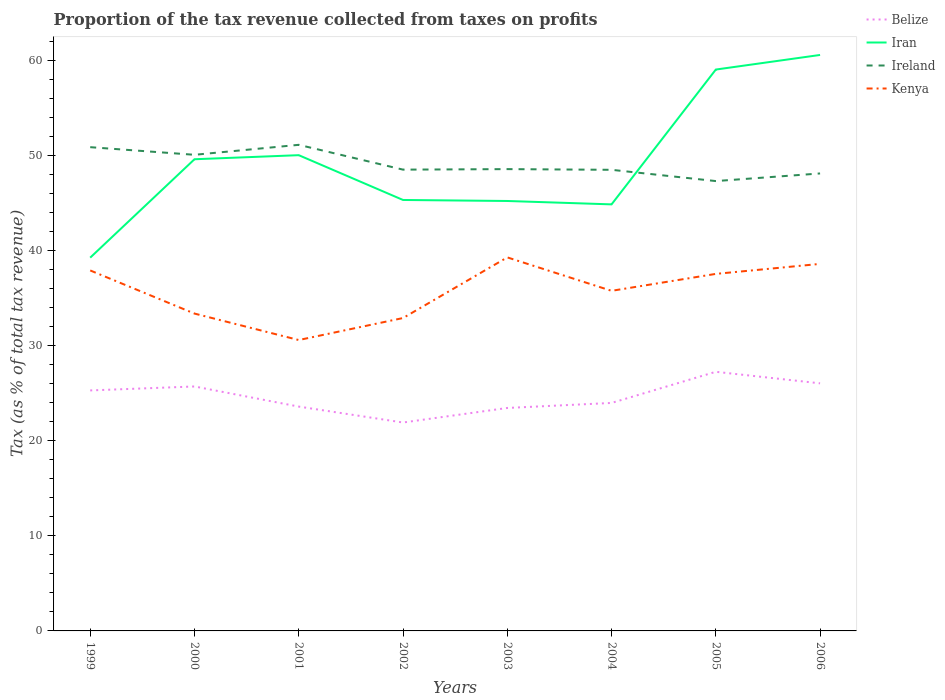How many different coloured lines are there?
Ensure brevity in your answer.  4. Does the line corresponding to Ireland intersect with the line corresponding to Kenya?
Your answer should be very brief. No. Across all years, what is the maximum proportion of the tax revenue collected in Ireland?
Provide a succinct answer. 47.34. What is the total proportion of the tax revenue collected in Kenya in the graph?
Your response must be concise. 5.01. What is the difference between the highest and the second highest proportion of the tax revenue collected in Ireland?
Provide a succinct answer. 3.81. Is the proportion of the tax revenue collected in Ireland strictly greater than the proportion of the tax revenue collected in Iran over the years?
Your answer should be very brief. No. What is the difference between two consecutive major ticks on the Y-axis?
Give a very brief answer. 10. Are the values on the major ticks of Y-axis written in scientific E-notation?
Your answer should be very brief. No. Does the graph contain grids?
Ensure brevity in your answer.  No. How are the legend labels stacked?
Make the answer very short. Vertical. What is the title of the graph?
Your answer should be very brief. Proportion of the tax revenue collected from taxes on profits. Does "Macedonia" appear as one of the legend labels in the graph?
Ensure brevity in your answer.  No. What is the label or title of the X-axis?
Provide a short and direct response. Years. What is the label or title of the Y-axis?
Make the answer very short. Tax (as % of total tax revenue). What is the Tax (as % of total tax revenue) of Belize in 1999?
Your response must be concise. 25.31. What is the Tax (as % of total tax revenue) in Iran in 1999?
Provide a short and direct response. 39.28. What is the Tax (as % of total tax revenue) of Ireland in 1999?
Offer a very short reply. 50.91. What is the Tax (as % of total tax revenue) of Kenya in 1999?
Offer a very short reply. 37.93. What is the Tax (as % of total tax revenue) in Belize in 2000?
Keep it short and to the point. 25.72. What is the Tax (as % of total tax revenue) of Iran in 2000?
Ensure brevity in your answer.  49.64. What is the Tax (as % of total tax revenue) of Ireland in 2000?
Make the answer very short. 50.11. What is the Tax (as % of total tax revenue) of Kenya in 2000?
Your answer should be very brief. 33.4. What is the Tax (as % of total tax revenue) in Belize in 2001?
Your response must be concise. 23.61. What is the Tax (as % of total tax revenue) of Iran in 2001?
Ensure brevity in your answer.  50.07. What is the Tax (as % of total tax revenue) of Ireland in 2001?
Offer a very short reply. 51.15. What is the Tax (as % of total tax revenue) of Kenya in 2001?
Provide a short and direct response. 30.61. What is the Tax (as % of total tax revenue) in Belize in 2002?
Ensure brevity in your answer.  21.93. What is the Tax (as % of total tax revenue) in Iran in 2002?
Your response must be concise. 45.35. What is the Tax (as % of total tax revenue) in Ireland in 2002?
Provide a succinct answer. 48.54. What is the Tax (as % of total tax revenue) in Kenya in 2002?
Provide a short and direct response. 32.93. What is the Tax (as % of total tax revenue) of Belize in 2003?
Provide a succinct answer. 23.46. What is the Tax (as % of total tax revenue) of Iran in 2003?
Your answer should be compact. 45.24. What is the Tax (as % of total tax revenue) in Ireland in 2003?
Make the answer very short. 48.6. What is the Tax (as % of total tax revenue) of Kenya in 2003?
Offer a terse response. 39.31. What is the Tax (as % of total tax revenue) of Belize in 2004?
Your response must be concise. 23.99. What is the Tax (as % of total tax revenue) of Iran in 2004?
Offer a very short reply. 44.89. What is the Tax (as % of total tax revenue) of Ireland in 2004?
Ensure brevity in your answer.  48.53. What is the Tax (as % of total tax revenue) in Kenya in 2004?
Your answer should be compact. 35.79. What is the Tax (as % of total tax revenue) in Belize in 2005?
Give a very brief answer. 27.27. What is the Tax (as % of total tax revenue) of Iran in 2005?
Your response must be concise. 59.08. What is the Tax (as % of total tax revenue) of Ireland in 2005?
Give a very brief answer. 47.34. What is the Tax (as % of total tax revenue) in Kenya in 2005?
Offer a very short reply. 37.57. What is the Tax (as % of total tax revenue) in Belize in 2006?
Offer a terse response. 26.05. What is the Tax (as % of total tax revenue) in Iran in 2006?
Make the answer very short. 60.61. What is the Tax (as % of total tax revenue) in Ireland in 2006?
Your answer should be compact. 48.14. What is the Tax (as % of total tax revenue) in Kenya in 2006?
Provide a short and direct response. 38.62. Across all years, what is the maximum Tax (as % of total tax revenue) in Belize?
Offer a terse response. 27.27. Across all years, what is the maximum Tax (as % of total tax revenue) in Iran?
Your response must be concise. 60.61. Across all years, what is the maximum Tax (as % of total tax revenue) of Ireland?
Make the answer very short. 51.15. Across all years, what is the maximum Tax (as % of total tax revenue) of Kenya?
Give a very brief answer. 39.31. Across all years, what is the minimum Tax (as % of total tax revenue) in Belize?
Keep it short and to the point. 21.93. Across all years, what is the minimum Tax (as % of total tax revenue) in Iran?
Your answer should be compact. 39.28. Across all years, what is the minimum Tax (as % of total tax revenue) of Ireland?
Provide a succinct answer. 47.34. Across all years, what is the minimum Tax (as % of total tax revenue) of Kenya?
Your answer should be compact. 30.61. What is the total Tax (as % of total tax revenue) of Belize in the graph?
Your answer should be very brief. 197.35. What is the total Tax (as % of total tax revenue) in Iran in the graph?
Provide a short and direct response. 394.15. What is the total Tax (as % of total tax revenue) of Ireland in the graph?
Ensure brevity in your answer.  393.31. What is the total Tax (as % of total tax revenue) in Kenya in the graph?
Provide a succinct answer. 286.16. What is the difference between the Tax (as % of total tax revenue) in Belize in 1999 and that in 2000?
Give a very brief answer. -0.42. What is the difference between the Tax (as % of total tax revenue) of Iran in 1999 and that in 2000?
Keep it short and to the point. -10.35. What is the difference between the Tax (as % of total tax revenue) in Ireland in 1999 and that in 2000?
Ensure brevity in your answer.  0.8. What is the difference between the Tax (as % of total tax revenue) in Kenya in 1999 and that in 2000?
Your answer should be compact. 4.54. What is the difference between the Tax (as % of total tax revenue) of Belize in 1999 and that in 2001?
Make the answer very short. 1.7. What is the difference between the Tax (as % of total tax revenue) in Iran in 1999 and that in 2001?
Your answer should be very brief. -10.78. What is the difference between the Tax (as % of total tax revenue) in Ireland in 1999 and that in 2001?
Give a very brief answer. -0.25. What is the difference between the Tax (as % of total tax revenue) in Kenya in 1999 and that in 2001?
Your answer should be very brief. 7.32. What is the difference between the Tax (as % of total tax revenue) of Belize in 1999 and that in 2002?
Offer a very short reply. 3.38. What is the difference between the Tax (as % of total tax revenue) in Iran in 1999 and that in 2002?
Keep it short and to the point. -6.07. What is the difference between the Tax (as % of total tax revenue) of Ireland in 1999 and that in 2002?
Your response must be concise. 2.36. What is the difference between the Tax (as % of total tax revenue) of Kenya in 1999 and that in 2002?
Your response must be concise. 5.01. What is the difference between the Tax (as % of total tax revenue) of Belize in 1999 and that in 2003?
Provide a short and direct response. 1.85. What is the difference between the Tax (as % of total tax revenue) in Iran in 1999 and that in 2003?
Your answer should be compact. -5.96. What is the difference between the Tax (as % of total tax revenue) of Ireland in 1999 and that in 2003?
Offer a terse response. 2.31. What is the difference between the Tax (as % of total tax revenue) of Kenya in 1999 and that in 2003?
Give a very brief answer. -1.37. What is the difference between the Tax (as % of total tax revenue) of Belize in 1999 and that in 2004?
Keep it short and to the point. 1.32. What is the difference between the Tax (as % of total tax revenue) in Iran in 1999 and that in 2004?
Make the answer very short. -5.61. What is the difference between the Tax (as % of total tax revenue) of Ireland in 1999 and that in 2004?
Give a very brief answer. 2.38. What is the difference between the Tax (as % of total tax revenue) in Kenya in 1999 and that in 2004?
Offer a terse response. 2.14. What is the difference between the Tax (as % of total tax revenue) of Belize in 1999 and that in 2005?
Your answer should be very brief. -1.96. What is the difference between the Tax (as % of total tax revenue) of Iran in 1999 and that in 2005?
Provide a succinct answer. -19.79. What is the difference between the Tax (as % of total tax revenue) of Ireland in 1999 and that in 2005?
Offer a terse response. 3.57. What is the difference between the Tax (as % of total tax revenue) of Kenya in 1999 and that in 2005?
Offer a terse response. 0.36. What is the difference between the Tax (as % of total tax revenue) in Belize in 1999 and that in 2006?
Ensure brevity in your answer.  -0.75. What is the difference between the Tax (as % of total tax revenue) of Iran in 1999 and that in 2006?
Offer a terse response. -21.33. What is the difference between the Tax (as % of total tax revenue) in Ireland in 1999 and that in 2006?
Make the answer very short. 2.76. What is the difference between the Tax (as % of total tax revenue) in Kenya in 1999 and that in 2006?
Keep it short and to the point. -0.69. What is the difference between the Tax (as % of total tax revenue) of Belize in 2000 and that in 2001?
Offer a terse response. 2.12. What is the difference between the Tax (as % of total tax revenue) of Iran in 2000 and that in 2001?
Your answer should be compact. -0.43. What is the difference between the Tax (as % of total tax revenue) in Ireland in 2000 and that in 2001?
Offer a very short reply. -1.05. What is the difference between the Tax (as % of total tax revenue) of Kenya in 2000 and that in 2001?
Offer a very short reply. 2.79. What is the difference between the Tax (as % of total tax revenue) in Belize in 2000 and that in 2002?
Give a very brief answer. 3.79. What is the difference between the Tax (as % of total tax revenue) in Iran in 2000 and that in 2002?
Give a very brief answer. 4.28. What is the difference between the Tax (as % of total tax revenue) in Ireland in 2000 and that in 2002?
Provide a short and direct response. 1.56. What is the difference between the Tax (as % of total tax revenue) of Kenya in 2000 and that in 2002?
Offer a terse response. 0.47. What is the difference between the Tax (as % of total tax revenue) in Belize in 2000 and that in 2003?
Give a very brief answer. 2.26. What is the difference between the Tax (as % of total tax revenue) in Iran in 2000 and that in 2003?
Give a very brief answer. 4.39. What is the difference between the Tax (as % of total tax revenue) of Ireland in 2000 and that in 2003?
Give a very brief answer. 1.51. What is the difference between the Tax (as % of total tax revenue) in Kenya in 2000 and that in 2003?
Your response must be concise. -5.91. What is the difference between the Tax (as % of total tax revenue) in Belize in 2000 and that in 2004?
Your answer should be compact. 1.73. What is the difference between the Tax (as % of total tax revenue) in Iran in 2000 and that in 2004?
Your answer should be very brief. 4.75. What is the difference between the Tax (as % of total tax revenue) in Ireland in 2000 and that in 2004?
Provide a short and direct response. 1.58. What is the difference between the Tax (as % of total tax revenue) of Kenya in 2000 and that in 2004?
Provide a short and direct response. -2.39. What is the difference between the Tax (as % of total tax revenue) of Belize in 2000 and that in 2005?
Provide a succinct answer. -1.54. What is the difference between the Tax (as % of total tax revenue) of Iran in 2000 and that in 2005?
Make the answer very short. -9.44. What is the difference between the Tax (as % of total tax revenue) of Ireland in 2000 and that in 2005?
Ensure brevity in your answer.  2.77. What is the difference between the Tax (as % of total tax revenue) of Kenya in 2000 and that in 2005?
Your response must be concise. -4.18. What is the difference between the Tax (as % of total tax revenue) in Belize in 2000 and that in 2006?
Ensure brevity in your answer.  -0.33. What is the difference between the Tax (as % of total tax revenue) of Iran in 2000 and that in 2006?
Make the answer very short. -10.98. What is the difference between the Tax (as % of total tax revenue) in Ireland in 2000 and that in 2006?
Provide a short and direct response. 1.96. What is the difference between the Tax (as % of total tax revenue) of Kenya in 2000 and that in 2006?
Your answer should be very brief. -5.23. What is the difference between the Tax (as % of total tax revenue) in Belize in 2001 and that in 2002?
Keep it short and to the point. 1.68. What is the difference between the Tax (as % of total tax revenue) of Iran in 2001 and that in 2002?
Provide a short and direct response. 4.71. What is the difference between the Tax (as % of total tax revenue) in Ireland in 2001 and that in 2002?
Your answer should be very brief. 2.61. What is the difference between the Tax (as % of total tax revenue) of Kenya in 2001 and that in 2002?
Provide a succinct answer. -2.31. What is the difference between the Tax (as % of total tax revenue) in Belize in 2001 and that in 2003?
Offer a terse response. 0.14. What is the difference between the Tax (as % of total tax revenue) in Iran in 2001 and that in 2003?
Make the answer very short. 4.82. What is the difference between the Tax (as % of total tax revenue) of Ireland in 2001 and that in 2003?
Give a very brief answer. 2.56. What is the difference between the Tax (as % of total tax revenue) in Kenya in 2001 and that in 2003?
Your answer should be compact. -8.7. What is the difference between the Tax (as % of total tax revenue) in Belize in 2001 and that in 2004?
Keep it short and to the point. -0.38. What is the difference between the Tax (as % of total tax revenue) in Iran in 2001 and that in 2004?
Your answer should be compact. 5.18. What is the difference between the Tax (as % of total tax revenue) in Ireland in 2001 and that in 2004?
Your response must be concise. 2.63. What is the difference between the Tax (as % of total tax revenue) of Kenya in 2001 and that in 2004?
Ensure brevity in your answer.  -5.18. What is the difference between the Tax (as % of total tax revenue) in Belize in 2001 and that in 2005?
Provide a short and direct response. -3.66. What is the difference between the Tax (as % of total tax revenue) of Iran in 2001 and that in 2005?
Ensure brevity in your answer.  -9.01. What is the difference between the Tax (as % of total tax revenue) of Ireland in 2001 and that in 2005?
Provide a short and direct response. 3.81. What is the difference between the Tax (as % of total tax revenue) of Kenya in 2001 and that in 2005?
Offer a very short reply. -6.96. What is the difference between the Tax (as % of total tax revenue) of Belize in 2001 and that in 2006?
Offer a very short reply. -2.45. What is the difference between the Tax (as % of total tax revenue) of Iran in 2001 and that in 2006?
Your answer should be compact. -10.55. What is the difference between the Tax (as % of total tax revenue) in Ireland in 2001 and that in 2006?
Provide a succinct answer. 3.01. What is the difference between the Tax (as % of total tax revenue) in Kenya in 2001 and that in 2006?
Provide a succinct answer. -8.01. What is the difference between the Tax (as % of total tax revenue) of Belize in 2002 and that in 2003?
Your answer should be compact. -1.53. What is the difference between the Tax (as % of total tax revenue) of Iran in 2002 and that in 2003?
Keep it short and to the point. 0.11. What is the difference between the Tax (as % of total tax revenue) of Ireland in 2002 and that in 2003?
Provide a short and direct response. -0.05. What is the difference between the Tax (as % of total tax revenue) of Kenya in 2002 and that in 2003?
Keep it short and to the point. -6.38. What is the difference between the Tax (as % of total tax revenue) of Belize in 2002 and that in 2004?
Your response must be concise. -2.06. What is the difference between the Tax (as % of total tax revenue) of Iran in 2002 and that in 2004?
Give a very brief answer. 0.46. What is the difference between the Tax (as % of total tax revenue) in Ireland in 2002 and that in 2004?
Ensure brevity in your answer.  0.02. What is the difference between the Tax (as % of total tax revenue) of Kenya in 2002 and that in 2004?
Give a very brief answer. -2.86. What is the difference between the Tax (as % of total tax revenue) of Belize in 2002 and that in 2005?
Offer a very short reply. -5.34. What is the difference between the Tax (as % of total tax revenue) of Iran in 2002 and that in 2005?
Your answer should be very brief. -13.72. What is the difference between the Tax (as % of total tax revenue) in Ireland in 2002 and that in 2005?
Make the answer very short. 1.2. What is the difference between the Tax (as % of total tax revenue) in Kenya in 2002 and that in 2005?
Make the answer very short. -4.65. What is the difference between the Tax (as % of total tax revenue) of Belize in 2002 and that in 2006?
Provide a short and direct response. -4.12. What is the difference between the Tax (as % of total tax revenue) in Iran in 2002 and that in 2006?
Provide a succinct answer. -15.26. What is the difference between the Tax (as % of total tax revenue) in Ireland in 2002 and that in 2006?
Your response must be concise. 0.4. What is the difference between the Tax (as % of total tax revenue) in Kenya in 2002 and that in 2006?
Ensure brevity in your answer.  -5.7. What is the difference between the Tax (as % of total tax revenue) in Belize in 2003 and that in 2004?
Keep it short and to the point. -0.53. What is the difference between the Tax (as % of total tax revenue) of Iran in 2003 and that in 2004?
Your answer should be very brief. 0.36. What is the difference between the Tax (as % of total tax revenue) in Ireland in 2003 and that in 2004?
Provide a short and direct response. 0.07. What is the difference between the Tax (as % of total tax revenue) in Kenya in 2003 and that in 2004?
Ensure brevity in your answer.  3.52. What is the difference between the Tax (as % of total tax revenue) in Belize in 2003 and that in 2005?
Offer a very short reply. -3.81. What is the difference between the Tax (as % of total tax revenue) of Iran in 2003 and that in 2005?
Your answer should be compact. -13.83. What is the difference between the Tax (as % of total tax revenue) in Ireland in 2003 and that in 2005?
Offer a very short reply. 1.26. What is the difference between the Tax (as % of total tax revenue) of Kenya in 2003 and that in 2005?
Make the answer very short. 1.74. What is the difference between the Tax (as % of total tax revenue) in Belize in 2003 and that in 2006?
Your answer should be compact. -2.59. What is the difference between the Tax (as % of total tax revenue) of Iran in 2003 and that in 2006?
Make the answer very short. -15.37. What is the difference between the Tax (as % of total tax revenue) in Ireland in 2003 and that in 2006?
Offer a very short reply. 0.46. What is the difference between the Tax (as % of total tax revenue) in Kenya in 2003 and that in 2006?
Offer a very short reply. 0.68. What is the difference between the Tax (as % of total tax revenue) of Belize in 2004 and that in 2005?
Ensure brevity in your answer.  -3.28. What is the difference between the Tax (as % of total tax revenue) of Iran in 2004 and that in 2005?
Provide a succinct answer. -14.19. What is the difference between the Tax (as % of total tax revenue) in Ireland in 2004 and that in 2005?
Your response must be concise. 1.19. What is the difference between the Tax (as % of total tax revenue) of Kenya in 2004 and that in 2005?
Provide a short and direct response. -1.78. What is the difference between the Tax (as % of total tax revenue) in Belize in 2004 and that in 2006?
Keep it short and to the point. -2.06. What is the difference between the Tax (as % of total tax revenue) in Iran in 2004 and that in 2006?
Make the answer very short. -15.72. What is the difference between the Tax (as % of total tax revenue) of Ireland in 2004 and that in 2006?
Offer a terse response. 0.38. What is the difference between the Tax (as % of total tax revenue) of Kenya in 2004 and that in 2006?
Your answer should be compact. -2.83. What is the difference between the Tax (as % of total tax revenue) in Belize in 2005 and that in 2006?
Offer a terse response. 1.21. What is the difference between the Tax (as % of total tax revenue) in Iran in 2005 and that in 2006?
Give a very brief answer. -1.54. What is the difference between the Tax (as % of total tax revenue) of Ireland in 2005 and that in 2006?
Keep it short and to the point. -0.8. What is the difference between the Tax (as % of total tax revenue) in Kenya in 2005 and that in 2006?
Your response must be concise. -1.05. What is the difference between the Tax (as % of total tax revenue) of Belize in 1999 and the Tax (as % of total tax revenue) of Iran in 2000?
Provide a short and direct response. -24.33. What is the difference between the Tax (as % of total tax revenue) in Belize in 1999 and the Tax (as % of total tax revenue) in Ireland in 2000?
Offer a very short reply. -24.8. What is the difference between the Tax (as % of total tax revenue) of Belize in 1999 and the Tax (as % of total tax revenue) of Kenya in 2000?
Your answer should be compact. -8.09. What is the difference between the Tax (as % of total tax revenue) of Iran in 1999 and the Tax (as % of total tax revenue) of Ireland in 2000?
Make the answer very short. -10.82. What is the difference between the Tax (as % of total tax revenue) in Iran in 1999 and the Tax (as % of total tax revenue) in Kenya in 2000?
Keep it short and to the point. 5.88. What is the difference between the Tax (as % of total tax revenue) in Ireland in 1999 and the Tax (as % of total tax revenue) in Kenya in 2000?
Offer a very short reply. 17.51. What is the difference between the Tax (as % of total tax revenue) of Belize in 1999 and the Tax (as % of total tax revenue) of Iran in 2001?
Keep it short and to the point. -24.76. What is the difference between the Tax (as % of total tax revenue) in Belize in 1999 and the Tax (as % of total tax revenue) in Ireland in 2001?
Keep it short and to the point. -25.84. What is the difference between the Tax (as % of total tax revenue) of Belize in 1999 and the Tax (as % of total tax revenue) of Kenya in 2001?
Your answer should be compact. -5.3. What is the difference between the Tax (as % of total tax revenue) of Iran in 1999 and the Tax (as % of total tax revenue) of Ireland in 2001?
Offer a very short reply. -11.87. What is the difference between the Tax (as % of total tax revenue) of Iran in 1999 and the Tax (as % of total tax revenue) of Kenya in 2001?
Your answer should be very brief. 8.67. What is the difference between the Tax (as % of total tax revenue) in Ireland in 1999 and the Tax (as % of total tax revenue) in Kenya in 2001?
Offer a very short reply. 20.3. What is the difference between the Tax (as % of total tax revenue) of Belize in 1999 and the Tax (as % of total tax revenue) of Iran in 2002?
Offer a terse response. -20.04. What is the difference between the Tax (as % of total tax revenue) in Belize in 1999 and the Tax (as % of total tax revenue) in Ireland in 2002?
Provide a short and direct response. -23.23. What is the difference between the Tax (as % of total tax revenue) of Belize in 1999 and the Tax (as % of total tax revenue) of Kenya in 2002?
Make the answer very short. -7.62. What is the difference between the Tax (as % of total tax revenue) of Iran in 1999 and the Tax (as % of total tax revenue) of Ireland in 2002?
Give a very brief answer. -9.26. What is the difference between the Tax (as % of total tax revenue) of Iran in 1999 and the Tax (as % of total tax revenue) of Kenya in 2002?
Provide a short and direct response. 6.36. What is the difference between the Tax (as % of total tax revenue) in Ireland in 1999 and the Tax (as % of total tax revenue) in Kenya in 2002?
Provide a short and direct response. 17.98. What is the difference between the Tax (as % of total tax revenue) in Belize in 1999 and the Tax (as % of total tax revenue) in Iran in 2003?
Your answer should be very brief. -19.93. What is the difference between the Tax (as % of total tax revenue) of Belize in 1999 and the Tax (as % of total tax revenue) of Ireland in 2003?
Give a very brief answer. -23.29. What is the difference between the Tax (as % of total tax revenue) in Belize in 1999 and the Tax (as % of total tax revenue) in Kenya in 2003?
Offer a very short reply. -14. What is the difference between the Tax (as % of total tax revenue) of Iran in 1999 and the Tax (as % of total tax revenue) of Ireland in 2003?
Provide a succinct answer. -9.32. What is the difference between the Tax (as % of total tax revenue) of Iran in 1999 and the Tax (as % of total tax revenue) of Kenya in 2003?
Offer a very short reply. -0.03. What is the difference between the Tax (as % of total tax revenue) in Ireland in 1999 and the Tax (as % of total tax revenue) in Kenya in 2003?
Offer a very short reply. 11.6. What is the difference between the Tax (as % of total tax revenue) of Belize in 1999 and the Tax (as % of total tax revenue) of Iran in 2004?
Provide a short and direct response. -19.58. What is the difference between the Tax (as % of total tax revenue) in Belize in 1999 and the Tax (as % of total tax revenue) in Ireland in 2004?
Provide a succinct answer. -23.22. What is the difference between the Tax (as % of total tax revenue) of Belize in 1999 and the Tax (as % of total tax revenue) of Kenya in 2004?
Ensure brevity in your answer.  -10.48. What is the difference between the Tax (as % of total tax revenue) of Iran in 1999 and the Tax (as % of total tax revenue) of Ireland in 2004?
Make the answer very short. -9.24. What is the difference between the Tax (as % of total tax revenue) of Iran in 1999 and the Tax (as % of total tax revenue) of Kenya in 2004?
Your response must be concise. 3.49. What is the difference between the Tax (as % of total tax revenue) in Ireland in 1999 and the Tax (as % of total tax revenue) in Kenya in 2004?
Your response must be concise. 15.12. What is the difference between the Tax (as % of total tax revenue) in Belize in 1999 and the Tax (as % of total tax revenue) in Iran in 2005?
Give a very brief answer. -33.77. What is the difference between the Tax (as % of total tax revenue) of Belize in 1999 and the Tax (as % of total tax revenue) of Ireland in 2005?
Ensure brevity in your answer.  -22.03. What is the difference between the Tax (as % of total tax revenue) of Belize in 1999 and the Tax (as % of total tax revenue) of Kenya in 2005?
Give a very brief answer. -12.26. What is the difference between the Tax (as % of total tax revenue) of Iran in 1999 and the Tax (as % of total tax revenue) of Ireland in 2005?
Your answer should be very brief. -8.06. What is the difference between the Tax (as % of total tax revenue) in Iran in 1999 and the Tax (as % of total tax revenue) in Kenya in 2005?
Your answer should be very brief. 1.71. What is the difference between the Tax (as % of total tax revenue) of Ireland in 1999 and the Tax (as % of total tax revenue) of Kenya in 2005?
Provide a succinct answer. 13.33. What is the difference between the Tax (as % of total tax revenue) in Belize in 1999 and the Tax (as % of total tax revenue) in Iran in 2006?
Your answer should be compact. -35.3. What is the difference between the Tax (as % of total tax revenue) in Belize in 1999 and the Tax (as % of total tax revenue) in Ireland in 2006?
Keep it short and to the point. -22.83. What is the difference between the Tax (as % of total tax revenue) in Belize in 1999 and the Tax (as % of total tax revenue) in Kenya in 2006?
Offer a terse response. -13.32. What is the difference between the Tax (as % of total tax revenue) of Iran in 1999 and the Tax (as % of total tax revenue) of Ireland in 2006?
Ensure brevity in your answer.  -8.86. What is the difference between the Tax (as % of total tax revenue) in Iran in 1999 and the Tax (as % of total tax revenue) in Kenya in 2006?
Your response must be concise. 0.66. What is the difference between the Tax (as % of total tax revenue) of Ireland in 1999 and the Tax (as % of total tax revenue) of Kenya in 2006?
Your answer should be compact. 12.28. What is the difference between the Tax (as % of total tax revenue) in Belize in 2000 and the Tax (as % of total tax revenue) in Iran in 2001?
Your answer should be compact. -24.34. What is the difference between the Tax (as % of total tax revenue) in Belize in 2000 and the Tax (as % of total tax revenue) in Ireland in 2001?
Provide a short and direct response. -25.43. What is the difference between the Tax (as % of total tax revenue) in Belize in 2000 and the Tax (as % of total tax revenue) in Kenya in 2001?
Provide a short and direct response. -4.89. What is the difference between the Tax (as % of total tax revenue) of Iran in 2000 and the Tax (as % of total tax revenue) of Ireland in 2001?
Keep it short and to the point. -1.52. What is the difference between the Tax (as % of total tax revenue) of Iran in 2000 and the Tax (as % of total tax revenue) of Kenya in 2001?
Give a very brief answer. 19.02. What is the difference between the Tax (as % of total tax revenue) in Ireland in 2000 and the Tax (as % of total tax revenue) in Kenya in 2001?
Keep it short and to the point. 19.49. What is the difference between the Tax (as % of total tax revenue) of Belize in 2000 and the Tax (as % of total tax revenue) of Iran in 2002?
Give a very brief answer. -19.63. What is the difference between the Tax (as % of total tax revenue) of Belize in 2000 and the Tax (as % of total tax revenue) of Ireland in 2002?
Make the answer very short. -22.82. What is the difference between the Tax (as % of total tax revenue) of Belize in 2000 and the Tax (as % of total tax revenue) of Kenya in 2002?
Your answer should be very brief. -7.2. What is the difference between the Tax (as % of total tax revenue) in Iran in 2000 and the Tax (as % of total tax revenue) in Ireland in 2002?
Offer a very short reply. 1.09. What is the difference between the Tax (as % of total tax revenue) in Iran in 2000 and the Tax (as % of total tax revenue) in Kenya in 2002?
Offer a terse response. 16.71. What is the difference between the Tax (as % of total tax revenue) in Ireland in 2000 and the Tax (as % of total tax revenue) in Kenya in 2002?
Your response must be concise. 17.18. What is the difference between the Tax (as % of total tax revenue) in Belize in 2000 and the Tax (as % of total tax revenue) in Iran in 2003?
Your response must be concise. -19.52. What is the difference between the Tax (as % of total tax revenue) of Belize in 2000 and the Tax (as % of total tax revenue) of Ireland in 2003?
Provide a short and direct response. -22.87. What is the difference between the Tax (as % of total tax revenue) of Belize in 2000 and the Tax (as % of total tax revenue) of Kenya in 2003?
Your answer should be compact. -13.58. What is the difference between the Tax (as % of total tax revenue) of Iran in 2000 and the Tax (as % of total tax revenue) of Ireland in 2003?
Provide a short and direct response. 1.04. What is the difference between the Tax (as % of total tax revenue) in Iran in 2000 and the Tax (as % of total tax revenue) in Kenya in 2003?
Your answer should be very brief. 10.33. What is the difference between the Tax (as % of total tax revenue) in Ireland in 2000 and the Tax (as % of total tax revenue) in Kenya in 2003?
Your response must be concise. 10.8. What is the difference between the Tax (as % of total tax revenue) in Belize in 2000 and the Tax (as % of total tax revenue) in Iran in 2004?
Your response must be concise. -19.16. What is the difference between the Tax (as % of total tax revenue) of Belize in 2000 and the Tax (as % of total tax revenue) of Ireland in 2004?
Ensure brevity in your answer.  -22.8. What is the difference between the Tax (as % of total tax revenue) of Belize in 2000 and the Tax (as % of total tax revenue) of Kenya in 2004?
Your answer should be compact. -10.06. What is the difference between the Tax (as % of total tax revenue) of Iran in 2000 and the Tax (as % of total tax revenue) of Ireland in 2004?
Ensure brevity in your answer.  1.11. What is the difference between the Tax (as % of total tax revenue) of Iran in 2000 and the Tax (as % of total tax revenue) of Kenya in 2004?
Your response must be concise. 13.85. What is the difference between the Tax (as % of total tax revenue) in Ireland in 2000 and the Tax (as % of total tax revenue) in Kenya in 2004?
Provide a short and direct response. 14.32. What is the difference between the Tax (as % of total tax revenue) in Belize in 2000 and the Tax (as % of total tax revenue) in Iran in 2005?
Your response must be concise. -33.35. What is the difference between the Tax (as % of total tax revenue) in Belize in 2000 and the Tax (as % of total tax revenue) in Ireland in 2005?
Make the answer very short. -21.61. What is the difference between the Tax (as % of total tax revenue) in Belize in 2000 and the Tax (as % of total tax revenue) in Kenya in 2005?
Make the answer very short. -11.85. What is the difference between the Tax (as % of total tax revenue) of Iran in 2000 and the Tax (as % of total tax revenue) of Ireland in 2005?
Provide a short and direct response. 2.3. What is the difference between the Tax (as % of total tax revenue) in Iran in 2000 and the Tax (as % of total tax revenue) in Kenya in 2005?
Ensure brevity in your answer.  12.06. What is the difference between the Tax (as % of total tax revenue) in Ireland in 2000 and the Tax (as % of total tax revenue) in Kenya in 2005?
Your answer should be very brief. 12.53. What is the difference between the Tax (as % of total tax revenue) in Belize in 2000 and the Tax (as % of total tax revenue) in Iran in 2006?
Offer a very short reply. -34.89. What is the difference between the Tax (as % of total tax revenue) of Belize in 2000 and the Tax (as % of total tax revenue) of Ireland in 2006?
Offer a terse response. -22.42. What is the difference between the Tax (as % of total tax revenue) of Belize in 2000 and the Tax (as % of total tax revenue) of Kenya in 2006?
Your answer should be compact. -12.9. What is the difference between the Tax (as % of total tax revenue) in Iran in 2000 and the Tax (as % of total tax revenue) in Ireland in 2006?
Ensure brevity in your answer.  1.49. What is the difference between the Tax (as % of total tax revenue) in Iran in 2000 and the Tax (as % of total tax revenue) in Kenya in 2006?
Offer a terse response. 11.01. What is the difference between the Tax (as % of total tax revenue) of Ireland in 2000 and the Tax (as % of total tax revenue) of Kenya in 2006?
Your response must be concise. 11.48. What is the difference between the Tax (as % of total tax revenue) of Belize in 2001 and the Tax (as % of total tax revenue) of Iran in 2002?
Make the answer very short. -21.74. What is the difference between the Tax (as % of total tax revenue) of Belize in 2001 and the Tax (as % of total tax revenue) of Ireland in 2002?
Ensure brevity in your answer.  -24.94. What is the difference between the Tax (as % of total tax revenue) of Belize in 2001 and the Tax (as % of total tax revenue) of Kenya in 2002?
Give a very brief answer. -9.32. What is the difference between the Tax (as % of total tax revenue) of Iran in 2001 and the Tax (as % of total tax revenue) of Ireland in 2002?
Keep it short and to the point. 1.52. What is the difference between the Tax (as % of total tax revenue) of Iran in 2001 and the Tax (as % of total tax revenue) of Kenya in 2002?
Offer a terse response. 17.14. What is the difference between the Tax (as % of total tax revenue) of Ireland in 2001 and the Tax (as % of total tax revenue) of Kenya in 2002?
Offer a very short reply. 18.23. What is the difference between the Tax (as % of total tax revenue) of Belize in 2001 and the Tax (as % of total tax revenue) of Iran in 2003?
Provide a succinct answer. -21.64. What is the difference between the Tax (as % of total tax revenue) in Belize in 2001 and the Tax (as % of total tax revenue) in Ireland in 2003?
Your response must be concise. -24.99. What is the difference between the Tax (as % of total tax revenue) in Belize in 2001 and the Tax (as % of total tax revenue) in Kenya in 2003?
Make the answer very short. -15.7. What is the difference between the Tax (as % of total tax revenue) in Iran in 2001 and the Tax (as % of total tax revenue) in Ireland in 2003?
Offer a terse response. 1.47. What is the difference between the Tax (as % of total tax revenue) of Iran in 2001 and the Tax (as % of total tax revenue) of Kenya in 2003?
Your answer should be compact. 10.76. What is the difference between the Tax (as % of total tax revenue) in Ireland in 2001 and the Tax (as % of total tax revenue) in Kenya in 2003?
Provide a succinct answer. 11.85. What is the difference between the Tax (as % of total tax revenue) of Belize in 2001 and the Tax (as % of total tax revenue) of Iran in 2004?
Give a very brief answer. -21.28. What is the difference between the Tax (as % of total tax revenue) in Belize in 2001 and the Tax (as % of total tax revenue) in Ireland in 2004?
Your response must be concise. -24.92. What is the difference between the Tax (as % of total tax revenue) in Belize in 2001 and the Tax (as % of total tax revenue) in Kenya in 2004?
Your answer should be compact. -12.18. What is the difference between the Tax (as % of total tax revenue) of Iran in 2001 and the Tax (as % of total tax revenue) of Ireland in 2004?
Your answer should be very brief. 1.54. What is the difference between the Tax (as % of total tax revenue) of Iran in 2001 and the Tax (as % of total tax revenue) of Kenya in 2004?
Your answer should be very brief. 14.28. What is the difference between the Tax (as % of total tax revenue) in Ireland in 2001 and the Tax (as % of total tax revenue) in Kenya in 2004?
Provide a short and direct response. 15.36. What is the difference between the Tax (as % of total tax revenue) of Belize in 2001 and the Tax (as % of total tax revenue) of Iran in 2005?
Ensure brevity in your answer.  -35.47. What is the difference between the Tax (as % of total tax revenue) in Belize in 2001 and the Tax (as % of total tax revenue) in Ireland in 2005?
Keep it short and to the point. -23.73. What is the difference between the Tax (as % of total tax revenue) of Belize in 2001 and the Tax (as % of total tax revenue) of Kenya in 2005?
Keep it short and to the point. -13.96. What is the difference between the Tax (as % of total tax revenue) in Iran in 2001 and the Tax (as % of total tax revenue) in Ireland in 2005?
Offer a very short reply. 2.73. What is the difference between the Tax (as % of total tax revenue) in Iran in 2001 and the Tax (as % of total tax revenue) in Kenya in 2005?
Your answer should be compact. 12.49. What is the difference between the Tax (as % of total tax revenue) of Ireland in 2001 and the Tax (as % of total tax revenue) of Kenya in 2005?
Give a very brief answer. 13.58. What is the difference between the Tax (as % of total tax revenue) of Belize in 2001 and the Tax (as % of total tax revenue) of Iran in 2006?
Your answer should be very brief. -37. What is the difference between the Tax (as % of total tax revenue) in Belize in 2001 and the Tax (as % of total tax revenue) in Ireland in 2006?
Ensure brevity in your answer.  -24.53. What is the difference between the Tax (as % of total tax revenue) of Belize in 2001 and the Tax (as % of total tax revenue) of Kenya in 2006?
Ensure brevity in your answer.  -15.02. What is the difference between the Tax (as % of total tax revenue) in Iran in 2001 and the Tax (as % of total tax revenue) in Ireland in 2006?
Provide a short and direct response. 1.92. What is the difference between the Tax (as % of total tax revenue) of Iran in 2001 and the Tax (as % of total tax revenue) of Kenya in 2006?
Make the answer very short. 11.44. What is the difference between the Tax (as % of total tax revenue) of Ireland in 2001 and the Tax (as % of total tax revenue) of Kenya in 2006?
Your response must be concise. 12.53. What is the difference between the Tax (as % of total tax revenue) of Belize in 2002 and the Tax (as % of total tax revenue) of Iran in 2003?
Keep it short and to the point. -23.31. What is the difference between the Tax (as % of total tax revenue) in Belize in 2002 and the Tax (as % of total tax revenue) in Ireland in 2003?
Provide a short and direct response. -26.67. What is the difference between the Tax (as % of total tax revenue) in Belize in 2002 and the Tax (as % of total tax revenue) in Kenya in 2003?
Give a very brief answer. -17.38. What is the difference between the Tax (as % of total tax revenue) in Iran in 2002 and the Tax (as % of total tax revenue) in Ireland in 2003?
Ensure brevity in your answer.  -3.25. What is the difference between the Tax (as % of total tax revenue) in Iran in 2002 and the Tax (as % of total tax revenue) in Kenya in 2003?
Offer a very short reply. 6.04. What is the difference between the Tax (as % of total tax revenue) of Ireland in 2002 and the Tax (as % of total tax revenue) of Kenya in 2003?
Offer a terse response. 9.23. What is the difference between the Tax (as % of total tax revenue) of Belize in 2002 and the Tax (as % of total tax revenue) of Iran in 2004?
Provide a short and direct response. -22.96. What is the difference between the Tax (as % of total tax revenue) of Belize in 2002 and the Tax (as % of total tax revenue) of Ireland in 2004?
Make the answer very short. -26.59. What is the difference between the Tax (as % of total tax revenue) of Belize in 2002 and the Tax (as % of total tax revenue) of Kenya in 2004?
Your answer should be compact. -13.86. What is the difference between the Tax (as % of total tax revenue) of Iran in 2002 and the Tax (as % of total tax revenue) of Ireland in 2004?
Provide a succinct answer. -3.17. What is the difference between the Tax (as % of total tax revenue) of Iran in 2002 and the Tax (as % of total tax revenue) of Kenya in 2004?
Provide a succinct answer. 9.56. What is the difference between the Tax (as % of total tax revenue) in Ireland in 2002 and the Tax (as % of total tax revenue) in Kenya in 2004?
Keep it short and to the point. 12.75. What is the difference between the Tax (as % of total tax revenue) of Belize in 2002 and the Tax (as % of total tax revenue) of Iran in 2005?
Ensure brevity in your answer.  -37.14. What is the difference between the Tax (as % of total tax revenue) of Belize in 2002 and the Tax (as % of total tax revenue) of Ireland in 2005?
Make the answer very short. -25.41. What is the difference between the Tax (as % of total tax revenue) of Belize in 2002 and the Tax (as % of total tax revenue) of Kenya in 2005?
Ensure brevity in your answer.  -15.64. What is the difference between the Tax (as % of total tax revenue) of Iran in 2002 and the Tax (as % of total tax revenue) of Ireland in 2005?
Your response must be concise. -1.99. What is the difference between the Tax (as % of total tax revenue) of Iran in 2002 and the Tax (as % of total tax revenue) of Kenya in 2005?
Offer a terse response. 7.78. What is the difference between the Tax (as % of total tax revenue) in Ireland in 2002 and the Tax (as % of total tax revenue) in Kenya in 2005?
Your answer should be compact. 10.97. What is the difference between the Tax (as % of total tax revenue) of Belize in 2002 and the Tax (as % of total tax revenue) of Iran in 2006?
Keep it short and to the point. -38.68. What is the difference between the Tax (as % of total tax revenue) in Belize in 2002 and the Tax (as % of total tax revenue) in Ireland in 2006?
Ensure brevity in your answer.  -26.21. What is the difference between the Tax (as % of total tax revenue) of Belize in 2002 and the Tax (as % of total tax revenue) of Kenya in 2006?
Give a very brief answer. -16.69. What is the difference between the Tax (as % of total tax revenue) of Iran in 2002 and the Tax (as % of total tax revenue) of Ireland in 2006?
Offer a terse response. -2.79. What is the difference between the Tax (as % of total tax revenue) in Iran in 2002 and the Tax (as % of total tax revenue) in Kenya in 2006?
Ensure brevity in your answer.  6.73. What is the difference between the Tax (as % of total tax revenue) of Ireland in 2002 and the Tax (as % of total tax revenue) of Kenya in 2006?
Your answer should be compact. 9.92. What is the difference between the Tax (as % of total tax revenue) of Belize in 2003 and the Tax (as % of total tax revenue) of Iran in 2004?
Make the answer very short. -21.42. What is the difference between the Tax (as % of total tax revenue) in Belize in 2003 and the Tax (as % of total tax revenue) in Ireland in 2004?
Offer a terse response. -25.06. What is the difference between the Tax (as % of total tax revenue) in Belize in 2003 and the Tax (as % of total tax revenue) in Kenya in 2004?
Your answer should be compact. -12.33. What is the difference between the Tax (as % of total tax revenue) in Iran in 2003 and the Tax (as % of total tax revenue) in Ireland in 2004?
Give a very brief answer. -3.28. What is the difference between the Tax (as % of total tax revenue) of Iran in 2003 and the Tax (as % of total tax revenue) of Kenya in 2004?
Your response must be concise. 9.45. What is the difference between the Tax (as % of total tax revenue) in Ireland in 2003 and the Tax (as % of total tax revenue) in Kenya in 2004?
Your answer should be very brief. 12.81. What is the difference between the Tax (as % of total tax revenue) in Belize in 2003 and the Tax (as % of total tax revenue) in Iran in 2005?
Offer a terse response. -35.61. What is the difference between the Tax (as % of total tax revenue) of Belize in 2003 and the Tax (as % of total tax revenue) of Ireland in 2005?
Keep it short and to the point. -23.88. What is the difference between the Tax (as % of total tax revenue) in Belize in 2003 and the Tax (as % of total tax revenue) in Kenya in 2005?
Your answer should be very brief. -14.11. What is the difference between the Tax (as % of total tax revenue) of Iran in 2003 and the Tax (as % of total tax revenue) of Ireland in 2005?
Keep it short and to the point. -2.1. What is the difference between the Tax (as % of total tax revenue) in Iran in 2003 and the Tax (as % of total tax revenue) in Kenya in 2005?
Make the answer very short. 7.67. What is the difference between the Tax (as % of total tax revenue) in Ireland in 2003 and the Tax (as % of total tax revenue) in Kenya in 2005?
Ensure brevity in your answer.  11.03. What is the difference between the Tax (as % of total tax revenue) in Belize in 2003 and the Tax (as % of total tax revenue) in Iran in 2006?
Your answer should be very brief. -37.15. What is the difference between the Tax (as % of total tax revenue) of Belize in 2003 and the Tax (as % of total tax revenue) of Ireland in 2006?
Offer a terse response. -24.68. What is the difference between the Tax (as % of total tax revenue) in Belize in 2003 and the Tax (as % of total tax revenue) in Kenya in 2006?
Provide a succinct answer. -15.16. What is the difference between the Tax (as % of total tax revenue) of Iran in 2003 and the Tax (as % of total tax revenue) of Ireland in 2006?
Keep it short and to the point. -2.9. What is the difference between the Tax (as % of total tax revenue) in Iran in 2003 and the Tax (as % of total tax revenue) in Kenya in 2006?
Your answer should be compact. 6.62. What is the difference between the Tax (as % of total tax revenue) of Ireland in 2003 and the Tax (as % of total tax revenue) of Kenya in 2006?
Keep it short and to the point. 9.97. What is the difference between the Tax (as % of total tax revenue) of Belize in 2004 and the Tax (as % of total tax revenue) of Iran in 2005?
Your answer should be compact. -35.08. What is the difference between the Tax (as % of total tax revenue) in Belize in 2004 and the Tax (as % of total tax revenue) in Ireland in 2005?
Offer a very short reply. -23.35. What is the difference between the Tax (as % of total tax revenue) in Belize in 2004 and the Tax (as % of total tax revenue) in Kenya in 2005?
Provide a succinct answer. -13.58. What is the difference between the Tax (as % of total tax revenue) in Iran in 2004 and the Tax (as % of total tax revenue) in Ireland in 2005?
Ensure brevity in your answer.  -2.45. What is the difference between the Tax (as % of total tax revenue) in Iran in 2004 and the Tax (as % of total tax revenue) in Kenya in 2005?
Keep it short and to the point. 7.32. What is the difference between the Tax (as % of total tax revenue) in Ireland in 2004 and the Tax (as % of total tax revenue) in Kenya in 2005?
Make the answer very short. 10.95. What is the difference between the Tax (as % of total tax revenue) in Belize in 2004 and the Tax (as % of total tax revenue) in Iran in 2006?
Your answer should be very brief. -36.62. What is the difference between the Tax (as % of total tax revenue) of Belize in 2004 and the Tax (as % of total tax revenue) of Ireland in 2006?
Your answer should be compact. -24.15. What is the difference between the Tax (as % of total tax revenue) of Belize in 2004 and the Tax (as % of total tax revenue) of Kenya in 2006?
Ensure brevity in your answer.  -14.63. What is the difference between the Tax (as % of total tax revenue) in Iran in 2004 and the Tax (as % of total tax revenue) in Ireland in 2006?
Your answer should be compact. -3.25. What is the difference between the Tax (as % of total tax revenue) in Iran in 2004 and the Tax (as % of total tax revenue) in Kenya in 2006?
Your answer should be very brief. 6.26. What is the difference between the Tax (as % of total tax revenue) of Ireland in 2004 and the Tax (as % of total tax revenue) of Kenya in 2006?
Offer a terse response. 9.9. What is the difference between the Tax (as % of total tax revenue) of Belize in 2005 and the Tax (as % of total tax revenue) of Iran in 2006?
Make the answer very short. -33.34. What is the difference between the Tax (as % of total tax revenue) in Belize in 2005 and the Tax (as % of total tax revenue) in Ireland in 2006?
Offer a terse response. -20.87. What is the difference between the Tax (as % of total tax revenue) in Belize in 2005 and the Tax (as % of total tax revenue) in Kenya in 2006?
Keep it short and to the point. -11.36. What is the difference between the Tax (as % of total tax revenue) in Iran in 2005 and the Tax (as % of total tax revenue) in Ireland in 2006?
Your answer should be very brief. 10.93. What is the difference between the Tax (as % of total tax revenue) in Iran in 2005 and the Tax (as % of total tax revenue) in Kenya in 2006?
Provide a succinct answer. 20.45. What is the difference between the Tax (as % of total tax revenue) in Ireland in 2005 and the Tax (as % of total tax revenue) in Kenya in 2006?
Give a very brief answer. 8.72. What is the average Tax (as % of total tax revenue) in Belize per year?
Ensure brevity in your answer.  24.67. What is the average Tax (as % of total tax revenue) of Iran per year?
Provide a succinct answer. 49.27. What is the average Tax (as % of total tax revenue) in Ireland per year?
Offer a very short reply. 49.16. What is the average Tax (as % of total tax revenue) of Kenya per year?
Provide a succinct answer. 35.77. In the year 1999, what is the difference between the Tax (as % of total tax revenue) in Belize and Tax (as % of total tax revenue) in Iran?
Offer a very short reply. -13.97. In the year 1999, what is the difference between the Tax (as % of total tax revenue) in Belize and Tax (as % of total tax revenue) in Ireland?
Your answer should be very brief. -25.6. In the year 1999, what is the difference between the Tax (as % of total tax revenue) in Belize and Tax (as % of total tax revenue) in Kenya?
Provide a short and direct response. -12.63. In the year 1999, what is the difference between the Tax (as % of total tax revenue) in Iran and Tax (as % of total tax revenue) in Ireland?
Provide a succinct answer. -11.63. In the year 1999, what is the difference between the Tax (as % of total tax revenue) in Iran and Tax (as % of total tax revenue) in Kenya?
Keep it short and to the point. 1.35. In the year 1999, what is the difference between the Tax (as % of total tax revenue) of Ireland and Tax (as % of total tax revenue) of Kenya?
Provide a succinct answer. 12.97. In the year 2000, what is the difference between the Tax (as % of total tax revenue) in Belize and Tax (as % of total tax revenue) in Iran?
Offer a terse response. -23.91. In the year 2000, what is the difference between the Tax (as % of total tax revenue) of Belize and Tax (as % of total tax revenue) of Ireland?
Ensure brevity in your answer.  -24.38. In the year 2000, what is the difference between the Tax (as % of total tax revenue) in Belize and Tax (as % of total tax revenue) in Kenya?
Your answer should be very brief. -7.67. In the year 2000, what is the difference between the Tax (as % of total tax revenue) in Iran and Tax (as % of total tax revenue) in Ireland?
Offer a terse response. -0.47. In the year 2000, what is the difference between the Tax (as % of total tax revenue) of Iran and Tax (as % of total tax revenue) of Kenya?
Make the answer very short. 16.24. In the year 2000, what is the difference between the Tax (as % of total tax revenue) of Ireland and Tax (as % of total tax revenue) of Kenya?
Provide a short and direct response. 16.71. In the year 2001, what is the difference between the Tax (as % of total tax revenue) in Belize and Tax (as % of total tax revenue) in Iran?
Your answer should be very brief. -26.46. In the year 2001, what is the difference between the Tax (as % of total tax revenue) of Belize and Tax (as % of total tax revenue) of Ireland?
Ensure brevity in your answer.  -27.55. In the year 2001, what is the difference between the Tax (as % of total tax revenue) of Belize and Tax (as % of total tax revenue) of Kenya?
Keep it short and to the point. -7. In the year 2001, what is the difference between the Tax (as % of total tax revenue) in Iran and Tax (as % of total tax revenue) in Ireland?
Your answer should be very brief. -1.09. In the year 2001, what is the difference between the Tax (as % of total tax revenue) in Iran and Tax (as % of total tax revenue) in Kenya?
Provide a short and direct response. 19.45. In the year 2001, what is the difference between the Tax (as % of total tax revenue) in Ireland and Tax (as % of total tax revenue) in Kenya?
Your answer should be compact. 20.54. In the year 2002, what is the difference between the Tax (as % of total tax revenue) of Belize and Tax (as % of total tax revenue) of Iran?
Offer a terse response. -23.42. In the year 2002, what is the difference between the Tax (as % of total tax revenue) of Belize and Tax (as % of total tax revenue) of Ireland?
Offer a very short reply. -26.61. In the year 2002, what is the difference between the Tax (as % of total tax revenue) of Belize and Tax (as % of total tax revenue) of Kenya?
Make the answer very short. -10.99. In the year 2002, what is the difference between the Tax (as % of total tax revenue) of Iran and Tax (as % of total tax revenue) of Ireland?
Your response must be concise. -3.19. In the year 2002, what is the difference between the Tax (as % of total tax revenue) in Iran and Tax (as % of total tax revenue) in Kenya?
Your response must be concise. 12.43. In the year 2002, what is the difference between the Tax (as % of total tax revenue) of Ireland and Tax (as % of total tax revenue) of Kenya?
Offer a terse response. 15.62. In the year 2003, what is the difference between the Tax (as % of total tax revenue) in Belize and Tax (as % of total tax revenue) in Iran?
Your answer should be compact. -21.78. In the year 2003, what is the difference between the Tax (as % of total tax revenue) of Belize and Tax (as % of total tax revenue) of Ireland?
Your answer should be compact. -25.13. In the year 2003, what is the difference between the Tax (as % of total tax revenue) in Belize and Tax (as % of total tax revenue) in Kenya?
Your answer should be compact. -15.85. In the year 2003, what is the difference between the Tax (as % of total tax revenue) in Iran and Tax (as % of total tax revenue) in Ireland?
Your answer should be compact. -3.35. In the year 2003, what is the difference between the Tax (as % of total tax revenue) in Iran and Tax (as % of total tax revenue) in Kenya?
Provide a succinct answer. 5.94. In the year 2003, what is the difference between the Tax (as % of total tax revenue) in Ireland and Tax (as % of total tax revenue) in Kenya?
Ensure brevity in your answer.  9.29. In the year 2004, what is the difference between the Tax (as % of total tax revenue) of Belize and Tax (as % of total tax revenue) of Iran?
Give a very brief answer. -20.9. In the year 2004, what is the difference between the Tax (as % of total tax revenue) in Belize and Tax (as % of total tax revenue) in Ireland?
Provide a succinct answer. -24.53. In the year 2004, what is the difference between the Tax (as % of total tax revenue) in Belize and Tax (as % of total tax revenue) in Kenya?
Provide a short and direct response. -11.8. In the year 2004, what is the difference between the Tax (as % of total tax revenue) of Iran and Tax (as % of total tax revenue) of Ireland?
Offer a terse response. -3.64. In the year 2004, what is the difference between the Tax (as % of total tax revenue) of Iran and Tax (as % of total tax revenue) of Kenya?
Keep it short and to the point. 9.1. In the year 2004, what is the difference between the Tax (as % of total tax revenue) in Ireland and Tax (as % of total tax revenue) in Kenya?
Your answer should be very brief. 12.73. In the year 2005, what is the difference between the Tax (as % of total tax revenue) of Belize and Tax (as % of total tax revenue) of Iran?
Offer a very short reply. -31.81. In the year 2005, what is the difference between the Tax (as % of total tax revenue) of Belize and Tax (as % of total tax revenue) of Ireland?
Ensure brevity in your answer.  -20.07. In the year 2005, what is the difference between the Tax (as % of total tax revenue) in Belize and Tax (as % of total tax revenue) in Kenya?
Give a very brief answer. -10.3. In the year 2005, what is the difference between the Tax (as % of total tax revenue) in Iran and Tax (as % of total tax revenue) in Ireland?
Make the answer very short. 11.74. In the year 2005, what is the difference between the Tax (as % of total tax revenue) of Iran and Tax (as % of total tax revenue) of Kenya?
Keep it short and to the point. 21.5. In the year 2005, what is the difference between the Tax (as % of total tax revenue) in Ireland and Tax (as % of total tax revenue) in Kenya?
Your response must be concise. 9.77. In the year 2006, what is the difference between the Tax (as % of total tax revenue) of Belize and Tax (as % of total tax revenue) of Iran?
Your answer should be compact. -34.56. In the year 2006, what is the difference between the Tax (as % of total tax revenue) in Belize and Tax (as % of total tax revenue) in Ireland?
Your response must be concise. -22.09. In the year 2006, what is the difference between the Tax (as % of total tax revenue) of Belize and Tax (as % of total tax revenue) of Kenya?
Your response must be concise. -12.57. In the year 2006, what is the difference between the Tax (as % of total tax revenue) of Iran and Tax (as % of total tax revenue) of Ireland?
Your answer should be very brief. 12.47. In the year 2006, what is the difference between the Tax (as % of total tax revenue) in Iran and Tax (as % of total tax revenue) in Kenya?
Your answer should be compact. 21.99. In the year 2006, what is the difference between the Tax (as % of total tax revenue) of Ireland and Tax (as % of total tax revenue) of Kenya?
Make the answer very short. 9.52. What is the ratio of the Tax (as % of total tax revenue) in Belize in 1999 to that in 2000?
Your answer should be very brief. 0.98. What is the ratio of the Tax (as % of total tax revenue) in Iran in 1999 to that in 2000?
Your answer should be very brief. 0.79. What is the ratio of the Tax (as % of total tax revenue) in Kenya in 1999 to that in 2000?
Offer a terse response. 1.14. What is the ratio of the Tax (as % of total tax revenue) of Belize in 1999 to that in 2001?
Keep it short and to the point. 1.07. What is the ratio of the Tax (as % of total tax revenue) in Iran in 1999 to that in 2001?
Your answer should be compact. 0.78. What is the ratio of the Tax (as % of total tax revenue) in Kenya in 1999 to that in 2001?
Give a very brief answer. 1.24. What is the ratio of the Tax (as % of total tax revenue) in Belize in 1999 to that in 2002?
Make the answer very short. 1.15. What is the ratio of the Tax (as % of total tax revenue) in Iran in 1999 to that in 2002?
Your answer should be very brief. 0.87. What is the ratio of the Tax (as % of total tax revenue) of Ireland in 1999 to that in 2002?
Your response must be concise. 1.05. What is the ratio of the Tax (as % of total tax revenue) in Kenya in 1999 to that in 2002?
Provide a succinct answer. 1.15. What is the ratio of the Tax (as % of total tax revenue) in Belize in 1999 to that in 2003?
Provide a succinct answer. 1.08. What is the ratio of the Tax (as % of total tax revenue) in Iran in 1999 to that in 2003?
Your answer should be compact. 0.87. What is the ratio of the Tax (as % of total tax revenue) in Ireland in 1999 to that in 2003?
Offer a terse response. 1.05. What is the ratio of the Tax (as % of total tax revenue) in Kenya in 1999 to that in 2003?
Your answer should be very brief. 0.96. What is the ratio of the Tax (as % of total tax revenue) of Belize in 1999 to that in 2004?
Give a very brief answer. 1.05. What is the ratio of the Tax (as % of total tax revenue) of Iran in 1999 to that in 2004?
Keep it short and to the point. 0.88. What is the ratio of the Tax (as % of total tax revenue) of Ireland in 1999 to that in 2004?
Give a very brief answer. 1.05. What is the ratio of the Tax (as % of total tax revenue) of Kenya in 1999 to that in 2004?
Ensure brevity in your answer.  1.06. What is the ratio of the Tax (as % of total tax revenue) in Belize in 1999 to that in 2005?
Make the answer very short. 0.93. What is the ratio of the Tax (as % of total tax revenue) in Iran in 1999 to that in 2005?
Provide a short and direct response. 0.66. What is the ratio of the Tax (as % of total tax revenue) in Ireland in 1999 to that in 2005?
Provide a short and direct response. 1.08. What is the ratio of the Tax (as % of total tax revenue) in Kenya in 1999 to that in 2005?
Make the answer very short. 1.01. What is the ratio of the Tax (as % of total tax revenue) in Belize in 1999 to that in 2006?
Your response must be concise. 0.97. What is the ratio of the Tax (as % of total tax revenue) in Iran in 1999 to that in 2006?
Ensure brevity in your answer.  0.65. What is the ratio of the Tax (as % of total tax revenue) of Ireland in 1999 to that in 2006?
Provide a short and direct response. 1.06. What is the ratio of the Tax (as % of total tax revenue) of Kenya in 1999 to that in 2006?
Offer a terse response. 0.98. What is the ratio of the Tax (as % of total tax revenue) in Belize in 2000 to that in 2001?
Offer a very short reply. 1.09. What is the ratio of the Tax (as % of total tax revenue) in Iran in 2000 to that in 2001?
Give a very brief answer. 0.99. What is the ratio of the Tax (as % of total tax revenue) of Ireland in 2000 to that in 2001?
Offer a very short reply. 0.98. What is the ratio of the Tax (as % of total tax revenue) in Kenya in 2000 to that in 2001?
Your answer should be compact. 1.09. What is the ratio of the Tax (as % of total tax revenue) of Belize in 2000 to that in 2002?
Provide a short and direct response. 1.17. What is the ratio of the Tax (as % of total tax revenue) in Iran in 2000 to that in 2002?
Your response must be concise. 1.09. What is the ratio of the Tax (as % of total tax revenue) of Ireland in 2000 to that in 2002?
Your answer should be very brief. 1.03. What is the ratio of the Tax (as % of total tax revenue) of Kenya in 2000 to that in 2002?
Give a very brief answer. 1.01. What is the ratio of the Tax (as % of total tax revenue) in Belize in 2000 to that in 2003?
Offer a terse response. 1.1. What is the ratio of the Tax (as % of total tax revenue) of Iran in 2000 to that in 2003?
Provide a short and direct response. 1.1. What is the ratio of the Tax (as % of total tax revenue) in Ireland in 2000 to that in 2003?
Make the answer very short. 1.03. What is the ratio of the Tax (as % of total tax revenue) of Kenya in 2000 to that in 2003?
Ensure brevity in your answer.  0.85. What is the ratio of the Tax (as % of total tax revenue) of Belize in 2000 to that in 2004?
Provide a short and direct response. 1.07. What is the ratio of the Tax (as % of total tax revenue) in Iran in 2000 to that in 2004?
Your response must be concise. 1.11. What is the ratio of the Tax (as % of total tax revenue) in Ireland in 2000 to that in 2004?
Ensure brevity in your answer.  1.03. What is the ratio of the Tax (as % of total tax revenue) of Kenya in 2000 to that in 2004?
Offer a very short reply. 0.93. What is the ratio of the Tax (as % of total tax revenue) in Belize in 2000 to that in 2005?
Provide a short and direct response. 0.94. What is the ratio of the Tax (as % of total tax revenue) in Iran in 2000 to that in 2005?
Provide a short and direct response. 0.84. What is the ratio of the Tax (as % of total tax revenue) of Ireland in 2000 to that in 2005?
Give a very brief answer. 1.06. What is the ratio of the Tax (as % of total tax revenue) of Kenya in 2000 to that in 2005?
Ensure brevity in your answer.  0.89. What is the ratio of the Tax (as % of total tax revenue) in Belize in 2000 to that in 2006?
Provide a short and direct response. 0.99. What is the ratio of the Tax (as % of total tax revenue) in Iran in 2000 to that in 2006?
Offer a very short reply. 0.82. What is the ratio of the Tax (as % of total tax revenue) of Ireland in 2000 to that in 2006?
Offer a very short reply. 1.04. What is the ratio of the Tax (as % of total tax revenue) of Kenya in 2000 to that in 2006?
Ensure brevity in your answer.  0.86. What is the ratio of the Tax (as % of total tax revenue) in Belize in 2001 to that in 2002?
Offer a very short reply. 1.08. What is the ratio of the Tax (as % of total tax revenue) in Iran in 2001 to that in 2002?
Your response must be concise. 1.1. What is the ratio of the Tax (as % of total tax revenue) in Ireland in 2001 to that in 2002?
Give a very brief answer. 1.05. What is the ratio of the Tax (as % of total tax revenue) of Kenya in 2001 to that in 2002?
Provide a succinct answer. 0.93. What is the ratio of the Tax (as % of total tax revenue) of Iran in 2001 to that in 2003?
Your answer should be very brief. 1.11. What is the ratio of the Tax (as % of total tax revenue) in Ireland in 2001 to that in 2003?
Offer a very short reply. 1.05. What is the ratio of the Tax (as % of total tax revenue) in Kenya in 2001 to that in 2003?
Provide a short and direct response. 0.78. What is the ratio of the Tax (as % of total tax revenue) of Iran in 2001 to that in 2004?
Your answer should be very brief. 1.12. What is the ratio of the Tax (as % of total tax revenue) of Ireland in 2001 to that in 2004?
Offer a very short reply. 1.05. What is the ratio of the Tax (as % of total tax revenue) of Kenya in 2001 to that in 2004?
Ensure brevity in your answer.  0.86. What is the ratio of the Tax (as % of total tax revenue) of Belize in 2001 to that in 2005?
Offer a very short reply. 0.87. What is the ratio of the Tax (as % of total tax revenue) of Iran in 2001 to that in 2005?
Give a very brief answer. 0.85. What is the ratio of the Tax (as % of total tax revenue) in Ireland in 2001 to that in 2005?
Your answer should be compact. 1.08. What is the ratio of the Tax (as % of total tax revenue) of Kenya in 2001 to that in 2005?
Your answer should be very brief. 0.81. What is the ratio of the Tax (as % of total tax revenue) of Belize in 2001 to that in 2006?
Your answer should be very brief. 0.91. What is the ratio of the Tax (as % of total tax revenue) of Iran in 2001 to that in 2006?
Your answer should be compact. 0.83. What is the ratio of the Tax (as % of total tax revenue) of Ireland in 2001 to that in 2006?
Offer a very short reply. 1.06. What is the ratio of the Tax (as % of total tax revenue) in Kenya in 2001 to that in 2006?
Ensure brevity in your answer.  0.79. What is the ratio of the Tax (as % of total tax revenue) of Belize in 2002 to that in 2003?
Your answer should be very brief. 0.93. What is the ratio of the Tax (as % of total tax revenue) of Kenya in 2002 to that in 2003?
Your response must be concise. 0.84. What is the ratio of the Tax (as % of total tax revenue) in Belize in 2002 to that in 2004?
Your answer should be compact. 0.91. What is the ratio of the Tax (as % of total tax revenue) of Iran in 2002 to that in 2004?
Offer a terse response. 1.01. What is the ratio of the Tax (as % of total tax revenue) in Ireland in 2002 to that in 2004?
Provide a succinct answer. 1. What is the ratio of the Tax (as % of total tax revenue) of Belize in 2002 to that in 2005?
Ensure brevity in your answer.  0.8. What is the ratio of the Tax (as % of total tax revenue) of Iran in 2002 to that in 2005?
Your response must be concise. 0.77. What is the ratio of the Tax (as % of total tax revenue) of Ireland in 2002 to that in 2005?
Keep it short and to the point. 1.03. What is the ratio of the Tax (as % of total tax revenue) of Kenya in 2002 to that in 2005?
Ensure brevity in your answer.  0.88. What is the ratio of the Tax (as % of total tax revenue) of Belize in 2002 to that in 2006?
Make the answer very short. 0.84. What is the ratio of the Tax (as % of total tax revenue) in Iran in 2002 to that in 2006?
Keep it short and to the point. 0.75. What is the ratio of the Tax (as % of total tax revenue) of Ireland in 2002 to that in 2006?
Keep it short and to the point. 1.01. What is the ratio of the Tax (as % of total tax revenue) of Kenya in 2002 to that in 2006?
Offer a very short reply. 0.85. What is the ratio of the Tax (as % of total tax revenue) of Iran in 2003 to that in 2004?
Provide a succinct answer. 1.01. What is the ratio of the Tax (as % of total tax revenue) in Ireland in 2003 to that in 2004?
Provide a succinct answer. 1. What is the ratio of the Tax (as % of total tax revenue) in Kenya in 2003 to that in 2004?
Provide a short and direct response. 1.1. What is the ratio of the Tax (as % of total tax revenue) in Belize in 2003 to that in 2005?
Give a very brief answer. 0.86. What is the ratio of the Tax (as % of total tax revenue) of Iran in 2003 to that in 2005?
Your answer should be very brief. 0.77. What is the ratio of the Tax (as % of total tax revenue) of Ireland in 2003 to that in 2005?
Provide a succinct answer. 1.03. What is the ratio of the Tax (as % of total tax revenue) in Kenya in 2003 to that in 2005?
Provide a short and direct response. 1.05. What is the ratio of the Tax (as % of total tax revenue) in Belize in 2003 to that in 2006?
Make the answer very short. 0.9. What is the ratio of the Tax (as % of total tax revenue) of Iran in 2003 to that in 2006?
Give a very brief answer. 0.75. What is the ratio of the Tax (as % of total tax revenue) of Ireland in 2003 to that in 2006?
Provide a short and direct response. 1.01. What is the ratio of the Tax (as % of total tax revenue) in Kenya in 2003 to that in 2006?
Offer a terse response. 1.02. What is the ratio of the Tax (as % of total tax revenue) of Belize in 2004 to that in 2005?
Make the answer very short. 0.88. What is the ratio of the Tax (as % of total tax revenue) of Iran in 2004 to that in 2005?
Your response must be concise. 0.76. What is the ratio of the Tax (as % of total tax revenue) of Kenya in 2004 to that in 2005?
Your answer should be very brief. 0.95. What is the ratio of the Tax (as % of total tax revenue) in Belize in 2004 to that in 2006?
Provide a succinct answer. 0.92. What is the ratio of the Tax (as % of total tax revenue) of Iran in 2004 to that in 2006?
Ensure brevity in your answer.  0.74. What is the ratio of the Tax (as % of total tax revenue) of Ireland in 2004 to that in 2006?
Your answer should be very brief. 1.01. What is the ratio of the Tax (as % of total tax revenue) of Kenya in 2004 to that in 2006?
Offer a very short reply. 0.93. What is the ratio of the Tax (as % of total tax revenue) of Belize in 2005 to that in 2006?
Provide a succinct answer. 1.05. What is the ratio of the Tax (as % of total tax revenue) in Iran in 2005 to that in 2006?
Your answer should be very brief. 0.97. What is the ratio of the Tax (as % of total tax revenue) in Ireland in 2005 to that in 2006?
Offer a very short reply. 0.98. What is the ratio of the Tax (as % of total tax revenue) of Kenya in 2005 to that in 2006?
Provide a succinct answer. 0.97. What is the difference between the highest and the second highest Tax (as % of total tax revenue) of Belize?
Your response must be concise. 1.21. What is the difference between the highest and the second highest Tax (as % of total tax revenue) in Iran?
Offer a terse response. 1.54. What is the difference between the highest and the second highest Tax (as % of total tax revenue) in Ireland?
Offer a very short reply. 0.25. What is the difference between the highest and the second highest Tax (as % of total tax revenue) in Kenya?
Offer a terse response. 0.68. What is the difference between the highest and the lowest Tax (as % of total tax revenue) in Belize?
Ensure brevity in your answer.  5.34. What is the difference between the highest and the lowest Tax (as % of total tax revenue) of Iran?
Your answer should be very brief. 21.33. What is the difference between the highest and the lowest Tax (as % of total tax revenue) in Ireland?
Keep it short and to the point. 3.81. What is the difference between the highest and the lowest Tax (as % of total tax revenue) in Kenya?
Provide a succinct answer. 8.7. 